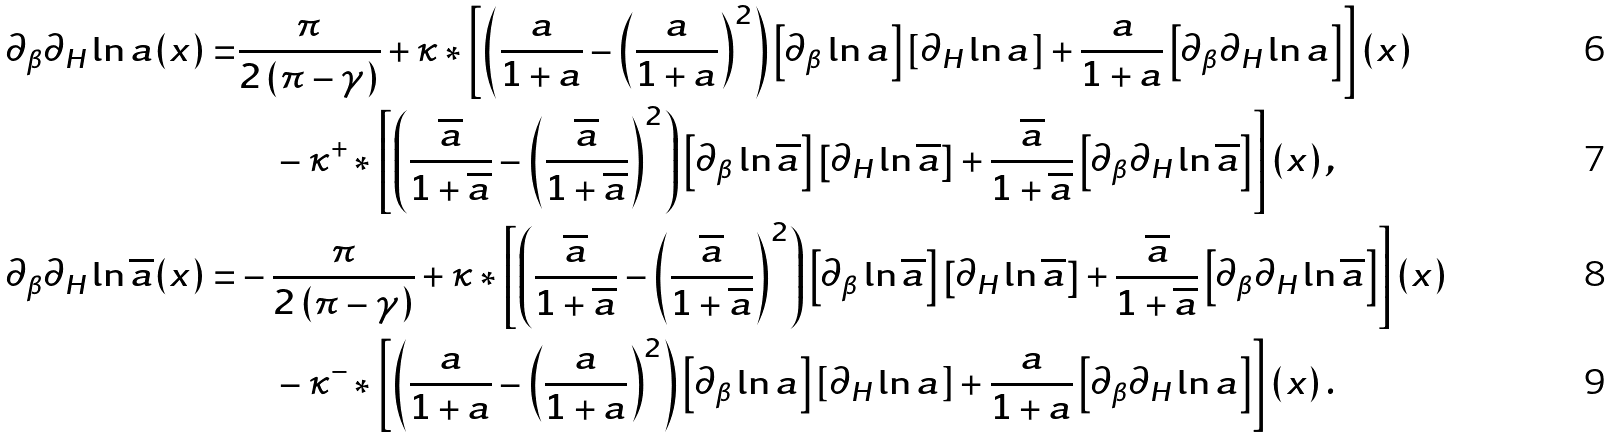Convert formula to latex. <formula><loc_0><loc_0><loc_500><loc_500>\partial _ { \beta } \partial _ { H } \ln a ( x ) = & \frac { \pi } { 2 \left ( \pi - \gamma \right ) } + \kappa * \left [ \left ( \frac { a } { 1 + a } - \left ( \frac { a } { 1 + a } \right ) ^ { 2 } \right ) \left [ \partial _ { \beta } \ln a \right ] \left [ \partial _ { H } \ln a \right ] + \frac { a } { 1 + a } \left [ \partial _ { \beta } \partial _ { H } \ln a \right ] \right ] ( x ) \\ & \quad - \kappa ^ { + } * \left [ \left ( \frac { \overline { a } } { 1 + \overline { a } } - \left ( \frac { \overline { a } } { 1 + \overline { a } } \right ) ^ { 2 } \right ) \left [ \partial _ { \beta } \ln \overline { a } \right ] \left [ \partial _ { H } \ln \overline { a } \right ] + \frac { \overline { a } } { 1 + \overline { a } } \left [ \partial _ { \beta } \partial _ { H } \ln \overline { a } \right ] \right ] ( x ) \, , \\ \partial _ { \beta } \partial _ { H } \ln \overline { a } ( x ) = & - \frac { \pi } { 2 \left ( \pi - \gamma \right ) } + \kappa * \left [ \left ( \frac { \overline { a } } { 1 + \overline { a } } - \left ( \frac { \overline { a } } { 1 + \overline { a } } \right ) ^ { 2 } \right ) \left [ \partial _ { \beta } \ln \overline { a } \right ] \left [ \partial _ { H } \ln \overline { a } \right ] + \frac { \overline { a } } { 1 + \overline { a } } \left [ \partial _ { \beta } \partial _ { H } \ln \overline { a } \right ] \right ] ( x ) \\ & \quad - \kappa ^ { - } * \left [ \left ( \frac { a } { 1 + a } - \left ( \frac { a } { 1 + a } \right ) ^ { 2 } \right ) \left [ \partial _ { \beta } \ln a \right ] \left [ \partial _ { H } \ln a \right ] + \frac { a } { 1 + a } \left [ \partial _ { \beta } \partial _ { H } \ln a \right ] \right ] ( x ) \, .</formula> 